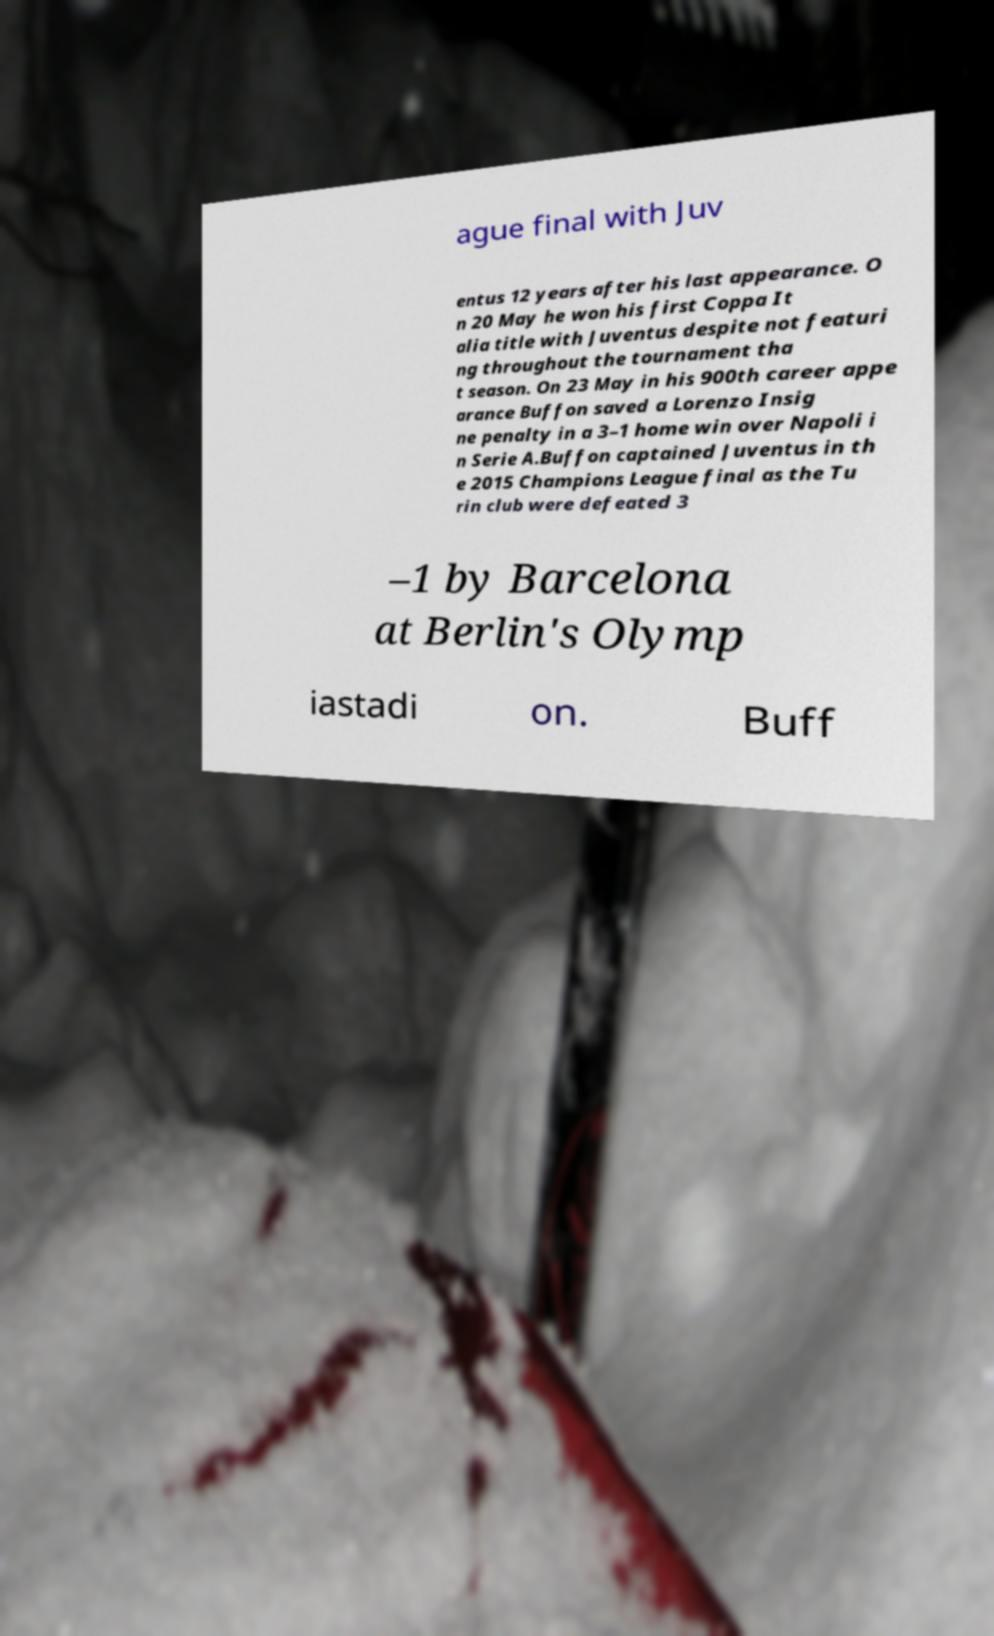Can you accurately transcribe the text from the provided image for me? ague final with Juv entus 12 years after his last appearance. O n 20 May he won his first Coppa It alia title with Juventus despite not featuri ng throughout the tournament tha t season. On 23 May in his 900th career appe arance Buffon saved a Lorenzo Insig ne penalty in a 3–1 home win over Napoli i n Serie A.Buffon captained Juventus in th e 2015 Champions League final as the Tu rin club were defeated 3 –1 by Barcelona at Berlin's Olymp iastadi on. Buff 